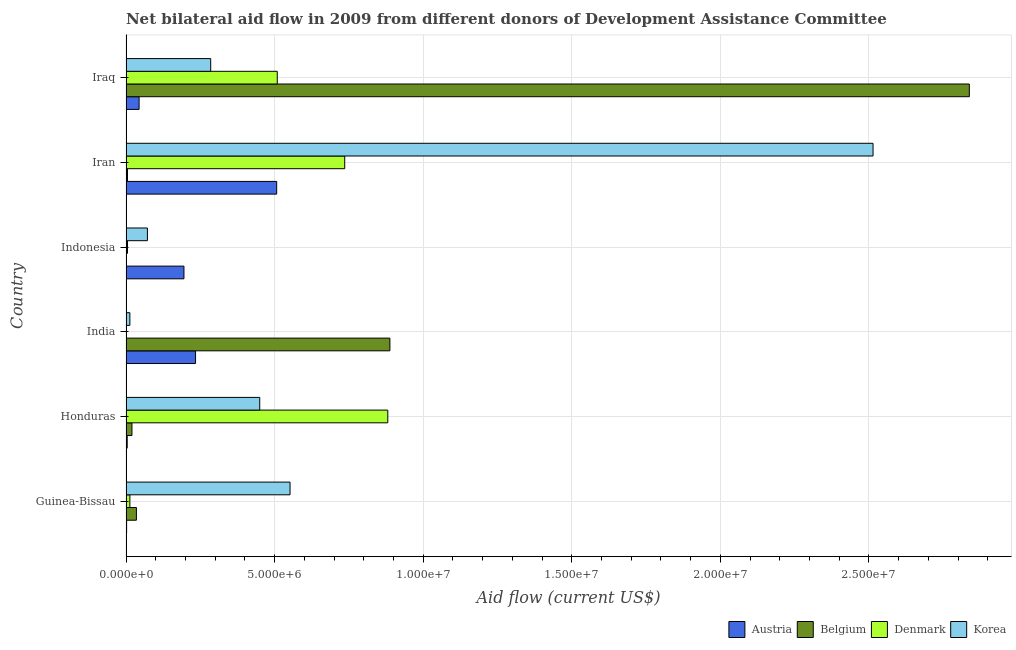How many groups of bars are there?
Provide a succinct answer. 6. Are the number of bars per tick equal to the number of legend labels?
Make the answer very short. No. Are the number of bars on each tick of the Y-axis equal?
Your answer should be very brief. No. How many bars are there on the 6th tick from the top?
Offer a terse response. 4. What is the label of the 4th group of bars from the top?
Your answer should be very brief. India. In how many cases, is the number of bars for a given country not equal to the number of legend labels?
Your answer should be very brief. 1. What is the amount of aid given by austria in India?
Your answer should be compact. 2.34e+06. Across all countries, what is the maximum amount of aid given by denmark?
Make the answer very short. 8.81e+06. Across all countries, what is the minimum amount of aid given by denmark?
Keep it short and to the point. 10000. In which country was the amount of aid given by korea maximum?
Give a very brief answer. Iran. What is the total amount of aid given by austria in the graph?
Keep it short and to the point. 9.86e+06. What is the difference between the amount of aid given by austria in Guinea-Bissau and that in India?
Give a very brief answer. -2.32e+06. What is the difference between the amount of aid given by korea in Honduras and the amount of aid given by austria in Indonesia?
Your answer should be very brief. 2.55e+06. What is the average amount of aid given by korea per country?
Make the answer very short. 6.48e+06. What is the difference between the amount of aid given by austria and amount of aid given by belgium in Honduras?
Give a very brief answer. -1.60e+05. What is the ratio of the amount of aid given by korea in Honduras to that in India?
Provide a short and direct response. 34.62. What is the difference between the highest and the second highest amount of aid given by korea?
Make the answer very short. 1.96e+07. What is the difference between the highest and the lowest amount of aid given by korea?
Your answer should be compact. 2.50e+07. Is it the case that in every country, the sum of the amount of aid given by austria and amount of aid given by denmark is greater than the sum of amount of aid given by korea and amount of aid given by belgium?
Provide a succinct answer. No. Is it the case that in every country, the sum of the amount of aid given by austria and amount of aid given by belgium is greater than the amount of aid given by denmark?
Provide a succinct answer. No. How many bars are there?
Make the answer very short. 23. Are all the bars in the graph horizontal?
Offer a very short reply. Yes. Does the graph contain any zero values?
Provide a succinct answer. Yes. How many legend labels are there?
Ensure brevity in your answer.  4. How are the legend labels stacked?
Keep it short and to the point. Horizontal. What is the title of the graph?
Provide a succinct answer. Net bilateral aid flow in 2009 from different donors of Development Assistance Committee. What is the Aid flow (current US$) of Korea in Guinea-Bissau?
Your answer should be very brief. 5.52e+06. What is the Aid flow (current US$) of Denmark in Honduras?
Keep it short and to the point. 8.81e+06. What is the Aid flow (current US$) of Korea in Honduras?
Make the answer very short. 4.50e+06. What is the Aid flow (current US$) in Austria in India?
Make the answer very short. 2.34e+06. What is the Aid flow (current US$) in Belgium in India?
Your answer should be very brief. 8.88e+06. What is the Aid flow (current US$) of Austria in Indonesia?
Provide a short and direct response. 1.95e+06. What is the Aid flow (current US$) of Denmark in Indonesia?
Your answer should be compact. 5.00e+04. What is the Aid flow (current US$) of Korea in Indonesia?
Your response must be concise. 7.20e+05. What is the Aid flow (current US$) of Austria in Iran?
Give a very brief answer. 5.07e+06. What is the Aid flow (current US$) of Belgium in Iran?
Make the answer very short. 5.00e+04. What is the Aid flow (current US$) of Denmark in Iran?
Offer a terse response. 7.36e+06. What is the Aid flow (current US$) in Korea in Iran?
Offer a terse response. 2.51e+07. What is the Aid flow (current US$) of Belgium in Iraq?
Your answer should be very brief. 2.84e+07. What is the Aid flow (current US$) of Denmark in Iraq?
Your response must be concise. 5.09e+06. What is the Aid flow (current US$) of Korea in Iraq?
Offer a very short reply. 2.85e+06. Across all countries, what is the maximum Aid flow (current US$) in Austria?
Offer a very short reply. 5.07e+06. Across all countries, what is the maximum Aid flow (current US$) of Belgium?
Keep it short and to the point. 2.84e+07. Across all countries, what is the maximum Aid flow (current US$) of Denmark?
Provide a short and direct response. 8.81e+06. Across all countries, what is the maximum Aid flow (current US$) in Korea?
Provide a short and direct response. 2.51e+07. Across all countries, what is the minimum Aid flow (current US$) in Belgium?
Your answer should be compact. 0. Across all countries, what is the minimum Aid flow (current US$) in Denmark?
Give a very brief answer. 10000. Across all countries, what is the minimum Aid flow (current US$) of Korea?
Offer a very short reply. 1.30e+05. What is the total Aid flow (current US$) of Austria in the graph?
Offer a very short reply. 9.86e+06. What is the total Aid flow (current US$) in Belgium in the graph?
Offer a very short reply. 3.79e+07. What is the total Aid flow (current US$) in Denmark in the graph?
Your answer should be very brief. 2.14e+07. What is the total Aid flow (current US$) in Korea in the graph?
Provide a succinct answer. 3.89e+07. What is the difference between the Aid flow (current US$) of Austria in Guinea-Bissau and that in Honduras?
Provide a short and direct response. -2.00e+04. What is the difference between the Aid flow (current US$) in Belgium in Guinea-Bissau and that in Honduras?
Ensure brevity in your answer.  1.50e+05. What is the difference between the Aid flow (current US$) of Denmark in Guinea-Bissau and that in Honduras?
Provide a short and direct response. -8.68e+06. What is the difference between the Aid flow (current US$) of Korea in Guinea-Bissau and that in Honduras?
Ensure brevity in your answer.  1.02e+06. What is the difference between the Aid flow (current US$) of Austria in Guinea-Bissau and that in India?
Your response must be concise. -2.32e+06. What is the difference between the Aid flow (current US$) of Belgium in Guinea-Bissau and that in India?
Offer a very short reply. -8.53e+06. What is the difference between the Aid flow (current US$) in Denmark in Guinea-Bissau and that in India?
Make the answer very short. 1.20e+05. What is the difference between the Aid flow (current US$) in Korea in Guinea-Bissau and that in India?
Provide a succinct answer. 5.39e+06. What is the difference between the Aid flow (current US$) in Austria in Guinea-Bissau and that in Indonesia?
Offer a very short reply. -1.93e+06. What is the difference between the Aid flow (current US$) in Korea in Guinea-Bissau and that in Indonesia?
Your response must be concise. 4.80e+06. What is the difference between the Aid flow (current US$) of Austria in Guinea-Bissau and that in Iran?
Give a very brief answer. -5.05e+06. What is the difference between the Aid flow (current US$) in Belgium in Guinea-Bissau and that in Iran?
Your answer should be very brief. 3.00e+05. What is the difference between the Aid flow (current US$) of Denmark in Guinea-Bissau and that in Iran?
Ensure brevity in your answer.  -7.23e+06. What is the difference between the Aid flow (current US$) of Korea in Guinea-Bissau and that in Iran?
Provide a succinct answer. -1.96e+07. What is the difference between the Aid flow (current US$) of Austria in Guinea-Bissau and that in Iraq?
Your answer should be very brief. -4.20e+05. What is the difference between the Aid flow (current US$) in Belgium in Guinea-Bissau and that in Iraq?
Make the answer very short. -2.80e+07. What is the difference between the Aid flow (current US$) of Denmark in Guinea-Bissau and that in Iraq?
Provide a short and direct response. -4.96e+06. What is the difference between the Aid flow (current US$) of Korea in Guinea-Bissau and that in Iraq?
Offer a terse response. 2.67e+06. What is the difference between the Aid flow (current US$) of Austria in Honduras and that in India?
Provide a succinct answer. -2.30e+06. What is the difference between the Aid flow (current US$) of Belgium in Honduras and that in India?
Offer a very short reply. -8.68e+06. What is the difference between the Aid flow (current US$) of Denmark in Honduras and that in India?
Ensure brevity in your answer.  8.80e+06. What is the difference between the Aid flow (current US$) of Korea in Honduras and that in India?
Your answer should be compact. 4.37e+06. What is the difference between the Aid flow (current US$) of Austria in Honduras and that in Indonesia?
Make the answer very short. -1.91e+06. What is the difference between the Aid flow (current US$) of Denmark in Honduras and that in Indonesia?
Your answer should be very brief. 8.76e+06. What is the difference between the Aid flow (current US$) in Korea in Honduras and that in Indonesia?
Provide a short and direct response. 3.78e+06. What is the difference between the Aid flow (current US$) of Austria in Honduras and that in Iran?
Make the answer very short. -5.03e+06. What is the difference between the Aid flow (current US$) of Denmark in Honduras and that in Iran?
Keep it short and to the point. 1.45e+06. What is the difference between the Aid flow (current US$) in Korea in Honduras and that in Iran?
Ensure brevity in your answer.  -2.06e+07. What is the difference between the Aid flow (current US$) in Austria in Honduras and that in Iraq?
Your response must be concise. -4.00e+05. What is the difference between the Aid flow (current US$) in Belgium in Honduras and that in Iraq?
Offer a terse response. -2.82e+07. What is the difference between the Aid flow (current US$) in Denmark in Honduras and that in Iraq?
Offer a very short reply. 3.72e+06. What is the difference between the Aid flow (current US$) in Korea in Honduras and that in Iraq?
Give a very brief answer. 1.65e+06. What is the difference between the Aid flow (current US$) in Austria in India and that in Indonesia?
Your answer should be very brief. 3.90e+05. What is the difference between the Aid flow (current US$) in Denmark in India and that in Indonesia?
Your answer should be compact. -4.00e+04. What is the difference between the Aid flow (current US$) in Korea in India and that in Indonesia?
Your response must be concise. -5.90e+05. What is the difference between the Aid flow (current US$) in Austria in India and that in Iran?
Keep it short and to the point. -2.73e+06. What is the difference between the Aid flow (current US$) in Belgium in India and that in Iran?
Offer a very short reply. 8.83e+06. What is the difference between the Aid flow (current US$) in Denmark in India and that in Iran?
Your response must be concise. -7.35e+06. What is the difference between the Aid flow (current US$) in Korea in India and that in Iran?
Give a very brief answer. -2.50e+07. What is the difference between the Aid flow (current US$) in Austria in India and that in Iraq?
Give a very brief answer. 1.90e+06. What is the difference between the Aid flow (current US$) of Belgium in India and that in Iraq?
Keep it short and to the point. -1.95e+07. What is the difference between the Aid flow (current US$) in Denmark in India and that in Iraq?
Make the answer very short. -5.08e+06. What is the difference between the Aid flow (current US$) in Korea in India and that in Iraq?
Your answer should be very brief. -2.72e+06. What is the difference between the Aid flow (current US$) of Austria in Indonesia and that in Iran?
Provide a succinct answer. -3.12e+06. What is the difference between the Aid flow (current US$) of Denmark in Indonesia and that in Iran?
Give a very brief answer. -7.31e+06. What is the difference between the Aid flow (current US$) of Korea in Indonesia and that in Iran?
Offer a terse response. -2.44e+07. What is the difference between the Aid flow (current US$) of Austria in Indonesia and that in Iraq?
Provide a short and direct response. 1.51e+06. What is the difference between the Aid flow (current US$) in Denmark in Indonesia and that in Iraq?
Your answer should be compact. -5.04e+06. What is the difference between the Aid flow (current US$) in Korea in Indonesia and that in Iraq?
Give a very brief answer. -2.13e+06. What is the difference between the Aid flow (current US$) in Austria in Iran and that in Iraq?
Your answer should be very brief. 4.63e+06. What is the difference between the Aid flow (current US$) in Belgium in Iran and that in Iraq?
Your answer should be very brief. -2.83e+07. What is the difference between the Aid flow (current US$) of Denmark in Iran and that in Iraq?
Ensure brevity in your answer.  2.27e+06. What is the difference between the Aid flow (current US$) in Korea in Iran and that in Iraq?
Your response must be concise. 2.23e+07. What is the difference between the Aid flow (current US$) in Austria in Guinea-Bissau and the Aid flow (current US$) in Belgium in Honduras?
Ensure brevity in your answer.  -1.80e+05. What is the difference between the Aid flow (current US$) of Austria in Guinea-Bissau and the Aid flow (current US$) of Denmark in Honduras?
Provide a succinct answer. -8.79e+06. What is the difference between the Aid flow (current US$) of Austria in Guinea-Bissau and the Aid flow (current US$) of Korea in Honduras?
Your answer should be very brief. -4.48e+06. What is the difference between the Aid flow (current US$) of Belgium in Guinea-Bissau and the Aid flow (current US$) of Denmark in Honduras?
Ensure brevity in your answer.  -8.46e+06. What is the difference between the Aid flow (current US$) of Belgium in Guinea-Bissau and the Aid flow (current US$) of Korea in Honduras?
Your answer should be compact. -4.15e+06. What is the difference between the Aid flow (current US$) in Denmark in Guinea-Bissau and the Aid flow (current US$) in Korea in Honduras?
Provide a short and direct response. -4.37e+06. What is the difference between the Aid flow (current US$) in Austria in Guinea-Bissau and the Aid flow (current US$) in Belgium in India?
Give a very brief answer. -8.86e+06. What is the difference between the Aid flow (current US$) of Denmark in Guinea-Bissau and the Aid flow (current US$) of Korea in India?
Your answer should be compact. 0. What is the difference between the Aid flow (current US$) in Austria in Guinea-Bissau and the Aid flow (current US$) in Denmark in Indonesia?
Your response must be concise. -3.00e+04. What is the difference between the Aid flow (current US$) in Austria in Guinea-Bissau and the Aid flow (current US$) in Korea in Indonesia?
Offer a terse response. -7.00e+05. What is the difference between the Aid flow (current US$) of Belgium in Guinea-Bissau and the Aid flow (current US$) of Denmark in Indonesia?
Your answer should be very brief. 3.00e+05. What is the difference between the Aid flow (current US$) in Belgium in Guinea-Bissau and the Aid flow (current US$) in Korea in Indonesia?
Your answer should be very brief. -3.70e+05. What is the difference between the Aid flow (current US$) of Denmark in Guinea-Bissau and the Aid flow (current US$) of Korea in Indonesia?
Ensure brevity in your answer.  -5.90e+05. What is the difference between the Aid flow (current US$) in Austria in Guinea-Bissau and the Aid flow (current US$) in Belgium in Iran?
Your answer should be very brief. -3.00e+04. What is the difference between the Aid flow (current US$) of Austria in Guinea-Bissau and the Aid flow (current US$) of Denmark in Iran?
Your response must be concise. -7.34e+06. What is the difference between the Aid flow (current US$) of Austria in Guinea-Bissau and the Aid flow (current US$) of Korea in Iran?
Ensure brevity in your answer.  -2.51e+07. What is the difference between the Aid flow (current US$) of Belgium in Guinea-Bissau and the Aid flow (current US$) of Denmark in Iran?
Provide a succinct answer. -7.01e+06. What is the difference between the Aid flow (current US$) in Belgium in Guinea-Bissau and the Aid flow (current US$) in Korea in Iran?
Your answer should be compact. -2.48e+07. What is the difference between the Aid flow (current US$) of Denmark in Guinea-Bissau and the Aid flow (current US$) of Korea in Iran?
Ensure brevity in your answer.  -2.50e+07. What is the difference between the Aid flow (current US$) in Austria in Guinea-Bissau and the Aid flow (current US$) in Belgium in Iraq?
Ensure brevity in your answer.  -2.84e+07. What is the difference between the Aid flow (current US$) of Austria in Guinea-Bissau and the Aid flow (current US$) of Denmark in Iraq?
Ensure brevity in your answer.  -5.07e+06. What is the difference between the Aid flow (current US$) of Austria in Guinea-Bissau and the Aid flow (current US$) of Korea in Iraq?
Your answer should be very brief. -2.83e+06. What is the difference between the Aid flow (current US$) in Belgium in Guinea-Bissau and the Aid flow (current US$) in Denmark in Iraq?
Offer a very short reply. -4.74e+06. What is the difference between the Aid flow (current US$) in Belgium in Guinea-Bissau and the Aid flow (current US$) in Korea in Iraq?
Offer a terse response. -2.50e+06. What is the difference between the Aid flow (current US$) in Denmark in Guinea-Bissau and the Aid flow (current US$) in Korea in Iraq?
Ensure brevity in your answer.  -2.72e+06. What is the difference between the Aid flow (current US$) of Austria in Honduras and the Aid flow (current US$) of Belgium in India?
Ensure brevity in your answer.  -8.84e+06. What is the difference between the Aid flow (current US$) in Austria in Honduras and the Aid flow (current US$) in Korea in India?
Make the answer very short. -9.00e+04. What is the difference between the Aid flow (current US$) of Belgium in Honduras and the Aid flow (current US$) of Denmark in India?
Offer a terse response. 1.90e+05. What is the difference between the Aid flow (current US$) in Belgium in Honduras and the Aid flow (current US$) in Korea in India?
Offer a very short reply. 7.00e+04. What is the difference between the Aid flow (current US$) in Denmark in Honduras and the Aid flow (current US$) in Korea in India?
Ensure brevity in your answer.  8.68e+06. What is the difference between the Aid flow (current US$) in Austria in Honduras and the Aid flow (current US$) in Denmark in Indonesia?
Offer a very short reply. -10000. What is the difference between the Aid flow (current US$) of Austria in Honduras and the Aid flow (current US$) of Korea in Indonesia?
Provide a short and direct response. -6.80e+05. What is the difference between the Aid flow (current US$) in Belgium in Honduras and the Aid flow (current US$) in Korea in Indonesia?
Offer a very short reply. -5.20e+05. What is the difference between the Aid flow (current US$) of Denmark in Honduras and the Aid flow (current US$) of Korea in Indonesia?
Make the answer very short. 8.09e+06. What is the difference between the Aid flow (current US$) in Austria in Honduras and the Aid flow (current US$) in Denmark in Iran?
Your answer should be compact. -7.32e+06. What is the difference between the Aid flow (current US$) in Austria in Honduras and the Aid flow (current US$) in Korea in Iran?
Offer a terse response. -2.51e+07. What is the difference between the Aid flow (current US$) of Belgium in Honduras and the Aid flow (current US$) of Denmark in Iran?
Offer a terse response. -7.16e+06. What is the difference between the Aid flow (current US$) of Belgium in Honduras and the Aid flow (current US$) of Korea in Iran?
Offer a terse response. -2.49e+07. What is the difference between the Aid flow (current US$) in Denmark in Honduras and the Aid flow (current US$) in Korea in Iran?
Make the answer very short. -1.63e+07. What is the difference between the Aid flow (current US$) in Austria in Honduras and the Aid flow (current US$) in Belgium in Iraq?
Provide a short and direct response. -2.83e+07. What is the difference between the Aid flow (current US$) in Austria in Honduras and the Aid flow (current US$) in Denmark in Iraq?
Your answer should be compact. -5.05e+06. What is the difference between the Aid flow (current US$) in Austria in Honduras and the Aid flow (current US$) in Korea in Iraq?
Keep it short and to the point. -2.81e+06. What is the difference between the Aid flow (current US$) in Belgium in Honduras and the Aid flow (current US$) in Denmark in Iraq?
Give a very brief answer. -4.89e+06. What is the difference between the Aid flow (current US$) in Belgium in Honduras and the Aid flow (current US$) in Korea in Iraq?
Keep it short and to the point. -2.65e+06. What is the difference between the Aid flow (current US$) in Denmark in Honduras and the Aid flow (current US$) in Korea in Iraq?
Offer a very short reply. 5.96e+06. What is the difference between the Aid flow (current US$) of Austria in India and the Aid flow (current US$) of Denmark in Indonesia?
Provide a short and direct response. 2.29e+06. What is the difference between the Aid flow (current US$) in Austria in India and the Aid flow (current US$) in Korea in Indonesia?
Your response must be concise. 1.62e+06. What is the difference between the Aid flow (current US$) of Belgium in India and the Aid flow (current US$) of Denmark in Indonesia?
Your response must be concise. 8.83e+06. What is the difference between the Aid flow (current US$) in Belgium in India and the Aid flow (current US$) in Korea in Indonesia?
Provide a succinct answer. 8.16e+06. What is the difference between the Aid flow (current US$) in Denmark in India and the Aid flow (current US$) in Korea in Indonesia?
Your answer should be very brief. -7.10e+05. What is the difference between the Aid flow (current US$) of Austria in India and the Aid flow (current US$) of Belgium in Iran?
Provide a short and direct response. 2.29e+06. What is the difference between the Aid flow (current US$) in Austria in India and the Aid flow (current US$) in Denmark in Iran?
Provide a short and direct response. -5.02e+06. What is the difference between the Aid flow (current US$) in Austria in India and the Aid flow (current US$) in Korea in Iran?
Ensure brevity in your answer.  -2.28e+07. What is the difference between the Aid flow (current US$) in Belgium in India and the Aid flow (current US$) in Denmark in Iran?
Make the answer very short. 1.52e+06. What is the difference between the Aid flow (current US$) of Belgium in India and the Aid flow (current US$) of Korea in Iran?
Provide a short and direct response. -1.63e+07. What is the difference between the Aid flow (current US$) in Denmark in India and the Aid flow (current US$) in Korea in Iran?
Your answer should be compact. -2.51e+07. What is the difference between the Aid flow (current US$) in Austria in India and the Aid flow (current US$) in Belgium in Iraq?
Ensure brevity in your answer.  -2.60e+07. What is the difference between the Aid flow (current US$) in Austria in India and the Aid flow (current US$) in Denmark in Iraq?
Your answer should be very brief. -2.75e+06. What is the difference between the Aid flow (current US$) of Austria in India and the Aid flow (current US$) of Korea in Iraq?
Your answer should be compact. -5.10e+05. What is the difference between the Aid flow (current US$) in Belgium in India and the Aid flow (current US$) in Denmark in Iraq?
Ensure brevity in your answer.  3.79e+06. What is the difference between the Aid flow (current US$) in Belgium in India and the Aid flow (current US$) in Korea in Iraq?
Provide a succinct answer. 6.03e+06. What is the difference between the Aid flow (current US$) of Denmark in India and the Aid flow (current US$) of Korea in Iraq?
Make the answer very short. -2.84e+06. What is the difference between the Aid flow (current US$) of Austria in Indonesia and the Aid flow (current US$) of Belgium in Iran?
Your response must be concise. 1.90e+06. What is the difference between the Aid flow (current US$) in Austria in Indonesia and the Aid flow (current US$) in Denmark in Iran?
Your answer should be compact. -5.41e+06. What is the difference between the Aid flow (current US$) in Austria in Indonesia and the Aid flow (current US$) in Korea in Iran?
Offer a terse response. -2.32e+07. What is the difference between the Aid flow (current US$) in Denmark in Indonesia and the Aid flow (current US$) in Korea in Iran?
Your response must be concise. -2.51e+07. What is the difference between the Aid flow (current US$) in Austria in Indonesia and the Aid flow (current US$) in Belgium in Iraq?
Your answer should be very brief. -2.64e+07. What is the difference between the Aid flow (current US$) of Austria in Indonesia and the Aid flow (current US$) of Denmark in Iraq?
Your answer should be compact. -3.14e+06. What is the difference between the Aid flow (current US$) in Austria in Indonesia and the Aid flow (current US$) in Korea in Iraq?
Ensure brevity in your answer.  -9.00e+05. What is the difference between the Aid flow (current US$) of Denmark in Indonesia and the Aid flow (current US$) of Korea in Iraq?
Provide a short and direct response. -2.80e+06. What is the difference between the Aid flow (current US$) in Austria in Iran and the Aid flow (current US$) in Belgium in Iraq?
Keep it short and to the point. -2.33e+07. What is the difference between the Aid flow (current US$) of Austria in Iran and the Aid flow (current US$) of Denmark in Iraq?
Provide a short and direct response. -2.00e+04. What is the difference between the Aid flow (current US$) of Austria in Iran and the Aid flow (current US$) of Korea in Iraq?
Your answer should be very brief. 2.22e+06. What is the difference between the Aid flow (current US$) of Belgium in Iran and the Aid flow (current US$) of Denmark in Iraq?
Offer a terse response. -5.04e+06. What is the difference between the Aid flow (current US$) in Belgium in Iran and the Aid flow (current US$) in Korea in Iraq?
Your answer should be very brief. -2.80e+06. What is the difference between the Aid flow (current US$) of Denmark in Iran and the Aid flow (current US$) of Korea in Iraq?
Ensure brevity in your answer.  4.51e+06. What is the average Aid flow (current US$) in Austria per country?
Your answer should be compact. 1.64e+06. What is the average Aid flow (current US$) in Belgium per country?
Your response must be concise. 6.31e+06. What is the average Aid flow (current US$) of Denmark per country?
Give a very brief answer. 3.58e+06. What is the average Aid flow (current US$) in Korea per country?
Make the answer very short. 6.48e+06. What is the difference between the Aid flow (current US$) of Austria and Aid flow (current US$) of Belgium in Guinea-Bissau?
Your answer should be very brief. -3.30e+05. What is the difference between the Aid flow (current US$) of Austria and Aid flow (current US$) of Korea in Guinea-Bissau?
Your response must be concise. -5.50e+06. What is the difference between the Aid flow (current US$) of Belgium and Aid flow (current US$) of Korea in Guinea-Bissau?
Offer a very short reply. -5.17e+06. What is the difference between the Aid flow (current US$) in Denmark and Aid flow (current US$) in Korea in Guinea-Bissau?
Your response must be concise. -5.39e+06. What is the difference between the Aid flow (current US$) in Austria and Aid flow (current US$) in Belgium in Honduras?
Give a very brief answer. -1.60e+05. What is the difference between the Aid flow (current US$) of Austria and Aid flow (current US$) of Denmark in Honduras?
Ensure brevity in your answer.  -8.77e+06. What is the difference between the Aid flow (current US$) in Austria and Aid flow (current US$) in Korea in Honduras?
Give a very brief answer. -4.46e+06. What is the difference between the Aid flow (current US$) in Belgium and Aid flow (current US$) in Denmark in Honduras?
Give a very brief answer. -8.61e+06. What is the difference between the Aid flow (current US$) of Belgium and Aid flow (current US$) of Korea in Honduras?
Your answer should be compact. -4.30e+06. What is the difference between the Aid flow (current US$) in Denmark and Aid flow (current US$) in Korea in Honduras?
Your answer should be very brief. 4.31e+06. What is the difference between the Aid flow (current US$) of Austria and Aid flow (current US$) of Belgium in India?
Offer a terse response. -6.54e+06. What is the difference between the Aid flow (current US$) of Austria and Aid flow (current US$) of Denmark in India?
Provide a short and direct response. 2.33e+06. What is the difference between the Aid flow (current US$) of Austria and Aid flow (current US$) of Korea in India?
Provide a succinct answer. 2.21e+06. What is the difference between the Aid flow (current US$) in Belgium and Aid flow (current US$) in Denmark in India?
Your response must be concise. 8.87e+06. What is the difference between the Aid flow (current US$) in Belgium and Aid flow (current US$) in Korea in India?
Offer a very short reply. 8.75e+06. What is the difference between the Aid flow (current US$) in Austria and Aid flow (current US$) in Denmark in Indonesia?
Provide a succinct answer. 1.90e+06. What is the difference between the Aid flow (current US$) in Austria and Aid flow (current US$) in Korea in Indonesia?
Ensure brevity in your answer.  1.23e+06. What is the difference between the Aid flow (current US$) of Denmark and Aid flow (current US$) of Korea in Indonesia?
Your answer should be compact. -6.70e+05. What is the difference between the Aid flow (current US$) in Austria and Aid flow (current US$) in Belgium in Iran?
Provide a succinct answer. 5.02e+06. What is the difference between the Aid flow (current US$) in Austria and Aid flow (current US$) in Denmark in Iran?
Make the answer very short. -2.29e+06. What is the difference between the Aid flow (current US$) of Austria and Aid flow (current US$) of Korea in Iran?
Offer a very short reply. -2.01e+07. What is the difference between the Aid flow (current US$) in Belgium and Aid flow (current US$) in Denmark in Iran?
Give a very brief answer. -7.31e+06. What is the difference between the Aid flow (current US$) in Belgium and Aid flow (current US$) in Korea in Iran?
Make the answer very short. -2.51e+07. What is the difference between the Aid flow (current US$) of Denmark and Aid flow (current US$) of Korea in Iran?
Keep it short and to the point. -1.78e+07. What is the difference between the Aid flow (current US$) of Austria and Aid flow (current US$) of Belgium in Iraq?
Give a very brief answer. -2.79e+07. What is the difference between the Aid flow (current US$) in Austria and Aid flow (current US$) in Denmark in Iraq?
Make the answer very short. -4.65e+06. What is the difference between the Aid flow (current US$) of Austria and Aid flow (current US$) of Korea in Iraq?
Provide a short and direct response. -2.41e+06. What is the difference between the Aid flow (current US$) in Belgium and Aid flow (current US$) in Denmark in Iraq?
Offer a terse response. 2.33e+07. What is the difference between the Aid flow (current US$) of Belgium and Aid flow (current US$) of Korea in Iraq?
Make the answer very short. 2.55e+07. What is the difference between the Aid flow (current US$) of Denmark and Aid flow (current US$) of Korea in Iraq?
Your answer should be very brief. 2.24e+06. What is the ratio of the Aid flow (current US$) of Belgium in Guinea-Bissau to that in Honduras?
Offer a very short reply. 1.75. What is the ratio of the Aid flow (current US$) of Denmark in Guinea-Bissau to that in Honduras?
Offer a very short reply. 0.01. What is the ratio of the Aid flow (current US$) of Korea in Guinea-Bissau to that in Honduras?
Your answer should be very brief. 1.23. What is the ratio of the Aid flow (current US$) of Austria in Guinea-Bissau to that in India?
Your answer should be very brief. 0.01. What is the ratio of the Aid flow (current US$) of Belgium in Guinea-Bissau to that in India?
Ensure brevity in your answer.  0.04. What is the ratio of the Aid flow (current US$) in Denmark in Guinea-Bissau to that in India?
Make the answer very short. 13. What is the ratio of the Aid flow (current US$) in Korea in Guinea-Bissau to that in India?
Ensure brevity in your answer.  42.46. What is the ratio of the Aid flow (current US$) of Austria in Guinea-Bissau to that in Indonesia?
Provide a short and direct response. 0.01. What is the ratio of the Aid flow (current US$) of Denmark in Guinea-Bissau to that in Indonesia?
Your answer should be very brief. 2.6. What is the ratio of the Aid flow (current US$) of Korea in Guinea-Bissau to that in Indonesia?
Make the answer very short. 7.67. What is the ratio of the Aid flow (current US$) of Austria in Guinea-Bissau to that in Iran?
Offer a terse response. 0. What is the ratio of the Aid flow (current US$) of Belgium in Guinea-Bissau to that in Iran?
Provide a short and direct response. 7. What is the ratio of the Aid flow (current US$) of Denmark in Guinea-Bissau to that in Iran?
Make the answer very short. 0.02. What is the ratio of the Aid flow (current US$) of Korea in Guinea-Bissau to that in Iran?
Make the answer very short. 0.22. What is the ratio of the Aid flow (current US$) in Austria in Guinea-Bissau to that in Iraq?
Provide a succinct answer. 0.05. What is the ratio of the Aid flow (current US$) in Belgium in Guinea-Bissau to that in Iraq?
Your answer should be very brief. 0.01. What is the ratio of the Aid flow (current US$) in Denmark in Guinea-Bissau to that in Iraq?
Give a very brief answer. 0.03. What is the ratio of the Aid flow (current US$) in Korea in Guinea-Bissau to that in Iraq?
Your answer should be compact. 1.94. What is the ratio of the Aid flow (current US$) in Austria in Honduras to that in India?
Provide a short and direct response. 0.02. What is the ratio of the Aid flow (current US$) in Belgium in Honduras to that in India?
Make the answer very short. 0.02. What is the ratio of the Aid flow (current US$) in Denmark in Honduras to that in India?
Give a very brief answer. 881. What is the ratio of the Aid flow (current US$) of Korea in Honduras to that in India?
Your answer should be very brief. 34.62. What is the ratio of the Aid flow (current US$) of Austria in Honduras to that in Indonesia?
Make the answer very short. 0.02. What is the ratio of the Aid flow (current US$) of Denmark in Honduras to that in Indonesia?
Offer a very short reply. 176.2. What is the ratio of the Aid flow (current US$) in Korea in Honduras to that in Indonesia?
Ensure brevity in your answer.  6.25. What is the ratio of the Aid flow (current US$) of Austria in Honduras to that in Iran?
Offer a very short reply. 0.01. What is the ratio of the Aid flow (current US$) of Belgium in Honduras to that in Iran?
Offer a very short reply. 4. What is the ratio of the Aid flow (current US$) of Denmark in Honduras to that in Iran?
Provide a short and direct response. 1.2. What is the ratio of the Aid flow (current US$) of Korea in Honduras to that in Iran?
Provide a succinct answer. 0.18. What is the ratio of the Aid flow (current US$) in Austria in Honduras to that in Iraq?
Make the answer very short. 0.09. What is the ratio of the Aid flow (current US$) in Belgium in Honduras to that in Iraq?
Make the answer very short. 0.01. What is the ratio of the Aid flow (current US$) in Denmark in Honduras to that in Iraq?
Your answer should be very brief. 1.73. What is the ratio of the Aid flow (current US$) in Korea in Honduras to that in Iraq?
Your response must be concise. 1.58. What is the ratio of the Aid flow (current US$) of Austria in India to that in Indonesia?
Offer a very short reply. 1.2. What is the ratio of the Aid flow (current US$) in Korea in India to that in Indonesia?
Provide a short and direct response. 0.18. What is the ratio of the Aid flow (current US$) of Austria in India to that in Iran?
Provide a short and direct response. 0.46. What is the ratio of the Aid flow (current US$) of Belgium in India to that in Iran?
Your answer should be very brief. 177.6. What is the ratio of the Aid flow (current US$) in Denmark in India to that in Iran?
Ensure brevity in your answer.  0. What is the ratio of the Aid flow (current US$) of Korea in India to that in Iran?
Your response must be concise. 0.01. What is the ratio of the Aid flow (current US$) of Austria in India to that in Iraq?
Keep it short and to the point. 5.32. What is the ratio of the Aid flow (current US$) in Belgium in India to that in Iraq?
Provide a succinct answer. 0.31. What is the ratio of the Aid flow (current US$) in Denmark in India to that in Iraq?
Offer a very short reply. 0. What is the ratio of the Aid flow (current US$) in Korea in India to that in Iraq?
Your answer should be compact. 0.05. What is the ratio of the Aid flow (current US$) in Austria in Indonesia to that in Iran?
Make the answer very short. 0.38. What is the ratio of the Aid flow (current US$) of Denmark in Indonesia to that in Iran?
Ensure brevity in your answer.  0.01. What is the ratio of the Aid flow (current US$) in Korea in Indonesia to that in Iran?
Your answer should be very brief. 0.03. What is the ratio of the Aid flow (current US$) of Austria in Indonesia to that in Iraq?
Your response must be concise. 4.43. What is the ratio of the Aid flow (current US$) in Denmark in Indonesia to that in Iraq?
Your answer should be compact. 0.01. What is the ratio of the Aid flow (current US$) in Korea in Indonesia to that in Iraq?
Keep it short and to the point. 0.25. What is the ratio of the Aid flow (current US$) in Austria in Iran to that in Iraq?
Your answer should be compact. 11.52. What is the ratio of the Aid flow (current US$) of Belgium in Iran to that in Iraq?
Ensure brevity in your answer.  0. What is the ratio of the Aid flow (current US$) in Denmark in Iran to that in Iraq?
Your answer should be compact. 1.45. What is the ratio of the Aid flow (current US$) in Korea in Iran to that in Iraq?
Provide a succinct answer. 8.82. What is the difference between the highest and the second highest Aid flow (current US$) of Austria?
Your answer should be very brief. 2.73e+06. What is the difference between the highest and the second highest Aid flow (current US$) of Belgium?
Offer a terse response. 1.95e+07. What is the difference between the highest and the second highest Aid flow (current US$) of Denmark?
Make the answer very short. 1.45e+06. What is the difference between the highest and the second highest Aid flow (current US$) of Korea?
Your answer should be compact. 1.96e+07. What is the difference between the highest and the lowest Aid flow (current US$) of Austria?
Your response must be concise. 5.05e+06. What is the difference between the highest and the lowest Aid flow (current US$) of Belgium?
Make the answer very short. 2.84e+07. What is the difference between the highest and the lowest Aid flow (current US$) of Denmark?
Keep it short and to the point. 8.80e+06. What is the difference between the highest and the lowest Aid flow (current US$) in Korea?
Offer a very short reply. 2.50e+07. 